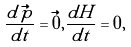<formula> <loc_0><loc_0><loc_500><loc_500>\frac { d \vec { p } } { d t } = \vec { 0 } , \frac { d H } { d t } = 0 ,</formula> 